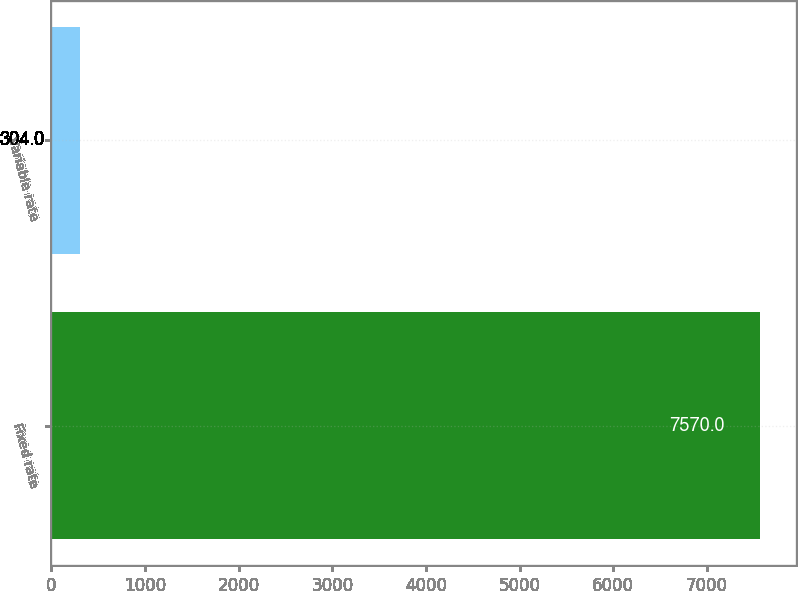<chart> <loc_0><loc_0><loc_500><loc_500><bar_chart><fcel>Fixed rate<fcel>Variable rate<nl><fcel>7570<fcel>304<nl></chart> 